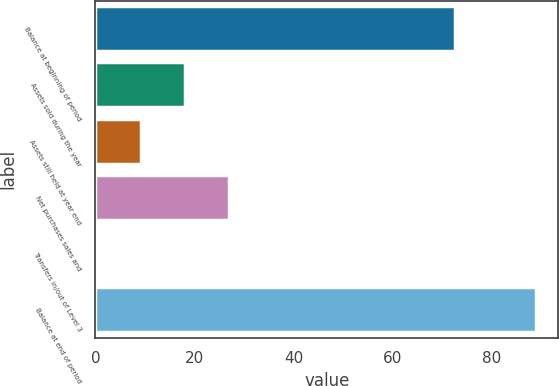<chart> <loc_0><loc_0><loc_500><loc_500><bar_chart><fcel>Balance at beginning of period<fcel>Assets sold during the year<fcel>Assets still held at year end<fcel>Net purchases sales and<fcel>Transfers in/out of Level 3<fcel>Balance at end of period<nl><fcel>72.5<fcel>18.1<fcel>9.25<fcel>26.95<fcel>0.4<fcel>88.9<nl></chart> 